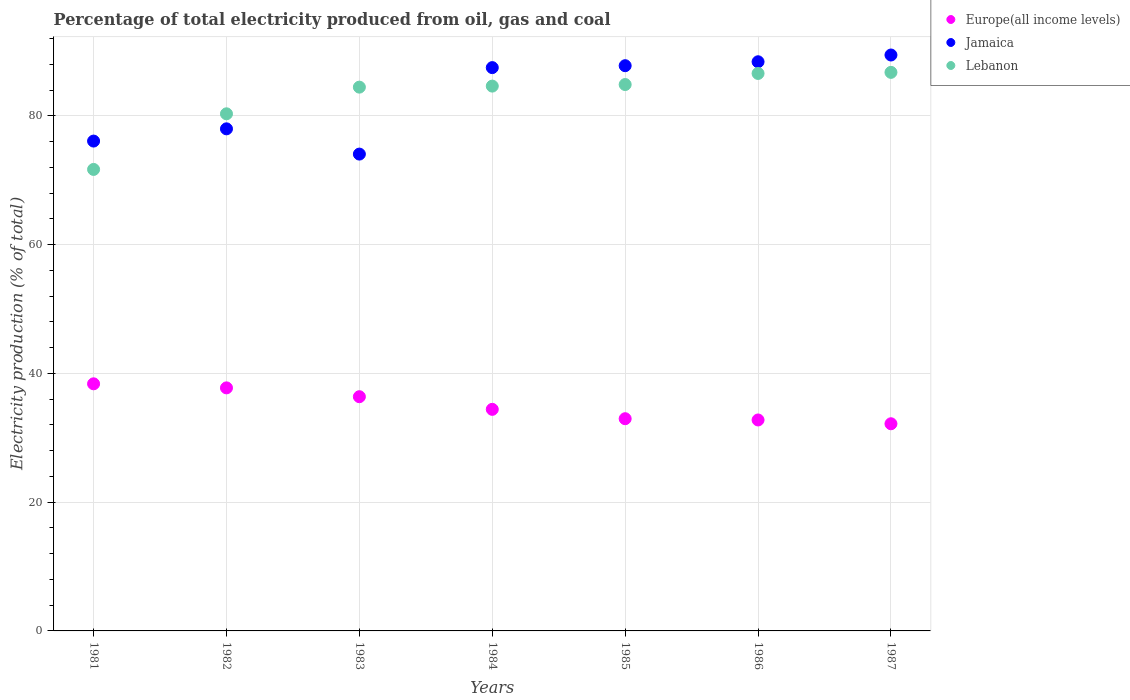Is the number of dotlines equal to the number of legend labels?
Provide a short and direct response. Yes. What is the electricity production in in Lebanon in 1981?
Your response must be concise. 71.67. Across all years, what is the maximum electricity production in in Jamaica?
Offer a very short reply. 89.43. Across all years, what is the minimum electricity production in in Lebanon?
Give a very brief answer. 71.67. In which year was the electricity production in in Jamaica minimum?
Offer a terse response. 1983. What is the total electricity production in in Jamaica in the graph?
Provide a succinct answer. 581.16. What is the difference between the electricity production in in Lebanon in 1984 and that in 1985?
Keep it short and to the point. -0.24. What is the difference between the electricity production in in Europe(all income levels) in 1985 and the electricity production in in Lebanon in 1987?
Keep it short and to the point. -53.78. What is the average electricity production in in Lebanon per year?
Offer a very short reply. 82.74. In the year 1982, what is the difference between the electricity production in in Europe(all income levels) and electricity production in in Lebanon?
Your answer should be very brief. -42.56. In how many years, is the electricity production in in Lebanon greater than 40 %?
Offer a very short reply. 7. What is the ratio of the electricity production in in Europe(all income levels) in 1982 to that in 1983?
Give a very brief answer. 1.04. Is the electricity production in in Europe(all income levels) in 1982 less than that in 1987?
Keep it short and to the point. No. What is the difference between the highest and the second highest electricity production in in Lebanon?
Give a very brief answer. 0.17. What is the difference between the highest and the lowest electricity production in in Europe(all income levels)?
Offer a terse response. 6.2. In how many years, is the electricity production in in Europe(all income levels) greater than the average electricity production in in Europe(all income levels) taken over all years?
Your response must be concise. 3. Does the electricity production in in Europe(all income levels) monotonically increase over the years?
Offer a terse response. No. Is the electricity production in in Europe(all income levels) strictly greater than the electricity production in in Jamaica over the years?
Your response must be concise. No. Is the electricity production in in Europe(all income levels) strictly less than the electricity production in in Jamaica over the years?
Your response must be concise. Yes. How many dotlines are there?
Provide a succinct answer. 3. How many years are there in the graph?
Provide a succinct answer. 7. Are the values on the major ticks of Y-axis written in scientific E-notation?
Provide a succinct answer. No. Does the graph contain any zero values?
Make the answer very short. No. Where does the legend appear in the graph?
Ensure brevity in your answer.  Top right. How many legend labels are there?
Offer a terse response. 3. How are the legend labels stacked?
Your response must be concise. Vertical. What is the title of the graph?
Provide a short and direct response. Percentage of total electricity produced from oil, gas and coal. Does "Monaco" appear as one of the legend labels in the graph?
Your answer should be very brief. No. What is the label or title of the Y-axis?
Offer a terse response. Electricity production (% of total). What is the Electricity production (% of total) in Europe(all income levels) in 1981?
Keep it short and to the point. 38.37. What is the Electricity production (% of total) of Jamaica in 1981?
Make the answer very short. 76.07. What is the Electricity production (% of total) of Lebanon in 1981?
Your answer should be very brief. 71.67. What is the Electricity production (% of total) of Europe(all income levels) in 1982?
Provide a short and direct response. 37.74. What is the Electricity production (% of total) in Jamaica in 1982?
Give a very brief answer. 77.97. What is the Electricity production (% of total) in Lebanon in 1982?
Offer a very short reply. 80.3. What is the Electricity production (% of total) of Europe(all income levels) in 1983?
Give a very brief answer. 36.37. What is the Electricity production (% of total) of Jamaica in 1983?
Make the answer very short. 74.05. What is the Electricity production (% of total) of Lebanon in 1983?
Give a very brief answer. 84.44. What is the Electricity production (% of total) of Europe(all income levels) in 1984?
Your response must be concise. 34.41. What is the Electricity production (% of total) of Jamaica in 1984?
Give a very brief answer. 87.48. What is the Electricity production (% of total) of Lebanon in 1984?
Offer a very short reply. 84.61. What is the Electricity production (% of total) in Europe(all income levels) in 1985?
Your answer should be compact. 32.95. What is the Electricity production (% of total) in Jamaica in 1985?
Provide a short and direct response. 87.78. What is the Electricity production (% of total) in Lebanon in 1985?
Ensure brevity in your answer.  84.85. What is the Electricity production (% of total) of Europe(all income levels) in 1986?
Your answer should be very brief. 32.76. What is the Electricity production (% of total) of Jamaica in 1986?
Make the answer very short. 88.39. What is the Electricity production (% of total) of Lebanon in 1986?
Your answer should be compact. 86.57. What is the Electricity production (% of total) in Europe(all income levels) in 1987?
Offer a very short reply. 32.17. What is the Electricity production (% of total) in Jamaica in 1987?
Make the answer very short. 89.43. What is the Electricity production (% of total) of Lebanon in 1987?
Offer a very short reply. 86.74. Across all years, what is the maximum Electricity production (% of total) in Europe(all income levels)?
Your answer should be compact. 38.37. Across all years, what is the maximum Electricity production (% of total) in Jamaica?
Make the answer very short. 89.43. Across all years, what is the maximum Electricity production (% of total) of Lebanon?
Make the answer very short. 86.74. Across all years, what is the minimum Electricity production (% of total) in Europe(all income levels)?
Your answer should be very brief. 32.17. Across all years, what is the minimum Electricity production (% of total) of Jamaica?
Make the answer very short. 74.05. Across all years, what is the minimum Electricity production (% of total) in Lebanon?
Provide a short and direct response. 71.67. What is the total Electricity production (% of total) in Europe(all income levels) in the graph?
Keep it short and to the point. 244.78. What is the total Electricity production (% of total) of Jamaica in the graph?
Provide a succinct answer. 581.16. What is the total Electricity production (% of total) of Lebanon in the graph?
Make the answer very short. 579.18. What is the difference between the Electricity production (% of total) of Europe(all income levels) in 1981 and that in 1982?
Make the answer very short. 0.63. What is the difference between the Electricity production (% of total) in Jamaica in 1981 and that in 1982?
Provide a succinct answer. -1.9. What is the difference between the Electricity production (% of total) of Lebanon in 1981 and that in 1982?
Provide a succinct answer. -8.64. What is the difference between the Electricity production (% of total) of Europe(all income levels) in 1981 and that in 1983?
Provide a short and direct response. 2. What is the difference between the Electricity production (% of total) in Jamaica in 1981 and that in 1983?
Make the answer very short. 2.02. What is the difference between the Electricity production (% of total) of Lebanon in 1981 and that in 1983?
Ensure brevity in your answer.  -12.78. What is the difference between the Electricity production (% of total) in Europe(all income levels) in 1981 and that in 1984?
Your answer should be compact. 3.96. What is the difference between the Electricity production (% of total) of Jamaica in 1981 and that in 1984?
Your answer should be compact. -11.41. What is the difference between the Electricity production (% of total) in Lebanon in 1981 and that in 1984?
Your answer should be very brief. -12.94. What is the difference between the Electricity production (% of total) in Europe(all income levels) in 1981 and that in 1985?
Provide a short and direct response. 5.42. What is the difference between the Electricity production (% of total) of Jamaica in 1981 and that in 1985?
Offer a very short reply. -11.71. What is the difference between the Electricity production (% of total) in Lebanon in 1981 and that in 1985?
Offer a very short reply. -13.18. What is the difference between the Electricity production (% of total) in Europe(all income levels) in 1981 and that in 1986?
Make the answer very short. 5.61. What is the difference between the Electricity production (% of total) of Jamaica in 1981 and that in 1986?
Make the answer very short. -12.32. What is the difference between the Electricity production (% of total) in Lebanon in 1981 and that in 1986?
Offer a very short reply. -14.9. What is the difference between the Electricity production (% of total) of Europe(all income levels) in 1981 and that in 1987?
Your response must be concise. 6.2. What is the difference between the Electricity production (% of total) of Jamaica in 1981 and that in 1987?
Offer a very short reply. -13.37. What is the difference between the Electricity production (% of total) of Lebanon in 1981 and that in 1987?
Offer a terse response. -15.07. What is the difference between the Electricity production (% of total) of Europe(all income levels) in 1982 and that in 1983?
Your response must be concise. 1.37. What is the difference between the Electricity production (% of total) in Jamaica in 1982 and that in 1983?
Your answer should be compact. 3.92. What is the difference between the Electricity production (% of total) of Lebanon in 1982 and that in 1983?
Keep it short and to the point. -4.14. What is the difference between the Electricity production (% of total) of Europe(all income levels) in 1982 and that in 1984?
Offer a terse response. 3.33. What is the difference between the Electricity production (% of total) of Jamaica in 1982 and that in 1984?
Give a very brief answer. -9.51. What is the difference between the Electricity production (% of total) of Lebanon in 1982 and that in 1984?
Keep it short and to the point. -4.3. What is the difference between the Electricity production (% of total) of Europe(all income levels) in 1982 and that in 1985?
Keep it short and to the point. 4.79. What is the difference between the Electricity production (% of total) in Jamaica in 1982 and that in 1985?
Offer a terse response. -9.81. What is the difference between the Electricity production (% of total) of Lebanon in 1982 and that in 1985?
Ensure brevity in your answer.  -4.55. What is the difference between the Electricity production (% of total) of Europe(all income levels) in 1982 and that in 1986?
Give a very brief answer. 4.98. What is the difference between the Electricity production (% of total) of Jamaica in 1982 and that in 1986?
Offer a very short reply. -10.42. What is the difference between the Electricity production (% of total) of Lebanon in 1982 and that in 1986?
Your answer should be very brief. -6.27. What is the difference between the Electricity production (% of total) of Europe(all income levels) in 1982 and that in 1987?
Keep it short and to the point. 5.57. What is the difference between the Electricity production (% of total) in Jamaica in 1982 and that in 1987?
Keep it short and to the point. -11.46. What is the difference between the Electricity production (% of total) in Lebanon in 1982 and that in 1987?
Keep it short and to the point. -6.44. What is the difference between the Electricity production (% of total) in Europe(all income levels) in 1983 and that in 1984?
Give a very brief answer. 1.96. What is the difference between the Electricity production (% of total) of Jamaica in 1983 and that in 1984?
Provide a short and direct response. -13.43. What is the difference between the Electricity production (% of total) of Lebanon in 1983 and that in 1984?
Offer a terse response. -0.16. What is the difference between the Electricity production (% of total) in Europe(all income levels) in 1983 and that in 1985?
Offer a very short reply. 3.42. What is the difference between the Electricity production (% of total) in Jamaica in 1983 and that in 1985?
Your answer should be very brief. -13.73. What is the difference between the Electricity production (% of total) of Lebanon in 1983 and that in 1985?
Offer a very short reply. -0.4. What is the difference between the Electricity production (% of total) in Europe(all income levels) in 1983 and that in 1986?
Offer a terse response. 3.61. What is the difference between the Electricity production (% of total) of Jamaica in 1983 and that in 1986?
Your response must be concise. -14.34. What is the difference between the Electricity production (% of total) in Lebanon in 1983 and that in 1986?
Your answer should be compact. -2.13. What is the difference between the Electricity production (% of total) in Europe(all income levels) in 1983 and that in 1987?
Your answer should be very brief. 4.2. What is the difference between the Electricity production (% of total) in Jamaica in 1983 and that in 1987?
Provide a succinct answer. -15.39. What is the difference between the Electricity production (% of total) in Lebanon in 1983 and that in 1987?
Your answer should be compact. -2.29. What is the difference between the Electricity production (% of total) of Europe(all income levels) in 1984 and that in 1985?
Keep it short and to the point. 1.45. What is the difference between the Electricity production (% of total) of Jamaica in 1984 and that in 1985?
Your answer should be compact. -0.3. What is the difference between the Electricity production (% of total) of Lebanon in 1984 and that in 1985?
Your response must be concise. -0.24. What is the difference between the Electricity production (% of total) in Europe(all income levels) in 1984 and that in 1986?
Provide a short and direct response. 1.65. What is the difference between the Electricity production (% of total) in Jamaica in 1984 and that in 1986?
Provide a succinct answer. -0.91. What is the difference between the Electricity production (% of total) of Lebanon in 1984 and that in 1986?
Your answer should be compact. -1.97. What is the difference between the Electricity production (% of total) of Europe(all income levels) in 1984 and that in 1987?
Your answer should be very brief. 2.24. What is the difference between the Electricity production (% of total) in Jamaica in 1984 and that in 1987?
Give a very brief answer. -1.96. What is the difference between the Electricity production (% of total) in Lebanon in 1984 and that in 1987?
Give a very brief answer. -2.13. What is the difference between the Electricity production (% of total) in Europe(all income levels) in 1985 and that in 1986?
Offer a terse response. 0.2. What is the difference between the Electricity production (% of total) of Jamaica in 1985 and that in 1986?
Make the answer very short. -0.61. What is the difference between the Electricity production (% of total) of Lebanon in 1985 and that in 1986?
Provide a short and direct response. -1.72. What is the difference between the Electricity production (% of total) in Europe(all income levels) in 1985 and that in 1987?
Your answer should be compact. 0.79. What is the difference between the Electricity production (% of total) of Jamaica in 1985 and that in 1987?
Your response must be concise. -1.66. What is the difference between the Electricity production (% of total) in Lebanon in 1985 and that in 1987?
Keep it short and to the point. -1.89. What is the difference between the Electricity production (% of total) of Europe(all income levels) in 1986 and that in 1987?
Provide a succinct answer. 0.59. What is the difference between the Electricity production (% of total) of Jamaica in 1986 and that in 1987?
Ensure brevity in your answer.  -1.05. What is the difference between the Electricity production (% of total) in Lebanon in 1986 and that in 1987?
Provide a short and direct response. -0.17. What is the difference between the Electricity production (% of total) in Europe(all income levels) in 1981 and the Electricity production (% of total) in Jamaica in 1982?
Offer a terse response. -39.6. What is the difference between the Electricity production (% of total) of Europe(all income levels) in 1981 and the Electricity production (% of total) of Lebanon in 1982?
Ensure brevity in your answer.  -41.93. What is the difference between the Electricity production (% of total) in Jamaica in 1981 and the Electricity production (% of total) in Lebanon in 1982?
Ensure brevity in your answer.  -4.23. What is the difference between the Electricity production (% of total) in Europe(all income levels) in 1981 and the Electricity production (% of total) in Jamaica in 1983?
Ensure brevity in your answer.  -35.67. What is the difference between the Electricity production (% of total) in Europe(all income levels) in 1981 and the Electricity production (% of total) in Lebanon in 1983?
Make the answer very short. -46.07. What is the difference between the Electricity production (% of total) of Jamaica in 1981 and the Electricity production (% of total) of Lebanon in 1983?
Your answer should be very brief. -8.38. What is the difference between the Electricity production (% of total) of Europe(all income levels) in 1981 and the Electricity production (% of total) of Jamaica in 1984?
Offer a terse response. -49.1. What is the difference between the Electricity production (% of total) of Europe(all income levels) in 1981 and the Electricity production (% of total) of Lebanon in 1984?
Your response must be concise. -46.23. What is the difference between the Electricity production (% of total) of Jamaica in 1981 and the Electricity production (% of total) of Lebanon in 1984?
Offer a terse response. -8.54. What is the difference between the Electricity production (% of total) of Europe(all income levels) in 1981 and the Electricity production (% of total) of Jamaica in 1985?
Make the answer very short. -49.4. What is the difference between the Electricity production (% of total) of Europe(all income levels) in 1981 and the Electricity production (% of total) of Lebanon in 1985?
Ensure brevity in your answer.  -46.47. What is the difference between the Electricity production (% of total) in Jamaica in 1981 and the Electricity production (% of total) in Lebanon in 1985?
Provide a succinct answer. -8.78. What is the difference between the Electricity production (% of total) in Europe(all income levels) in 1981 and the Electricity production (% of total) in Jamaica in 1986?
Ensure brevity in your answer.  -50.01. What is the difference between the Electricity production (% of total) in Europe(all income levels) in 1981 and the Electricity production (% of total) in Lebanon in 1986?
Your answer should be compact. -48.2. What is the difference between the Electricity production (% of total) of Jamaica in 1981 and the Electricity production (% of total) of Lebanon in 1986?
Offer a terse response. -10.5. What is the difference between the Electricity production (% of total) of Europe(all income levels) in 1981 and the Electricity production (% of total) of Jamaica in 1987?
Offer a terse response. -51.06. What is the difference between the Electricity production (% of total) of Europe(all income levels) in 1981 and the Electricity production (% of total) of Lebanon in 1987?
Provide a succinct answer. -48.37. What is the difference between the Electricity production (% of total) in Jamaica in 1981 and the Electricity production (% of total) in Lebanon in 1987?
Give a very brief answer. -10.67. What is the difference between the Electricity production (% of total) in Europe(all income levels) in 1982 and the Electricity production (% of total) in Jamaica in 1983?
Your answer should be very brief. -36.3. What is the difference between the Electricity production (% of total) in Europe(all income levels) in 1982 and the Electricity production (% of total) in Lebanon in 1983?
Ensure brevity in your answer.  -46.7. What is the difference between the Electricity production (% of total) in Jamaica in 1982 and the Electricity production (% of total) in Lebanon in 1983?
Give a very brief answer. -6.47. What is the difference between the Electricity production (% of total) in Europe(all income levels) in 1982 and the Electricity production (% of total) in Jamaica in 1984?
Offer a very short reply. -49.73. What is the difference between the Electricity production (% of total) in Europe(all income levels) in 1982 and the Electricity production (% of total) in Lebanon in 1984?
Offer a very short reply. -46.86. What is the difference between the Electricity production (% of total) of Jamaica in 1982 and the Electricity production (% of total) of Lebanon in 1984?
Ensure brevity in your answer.  -6.64. What is the difference between the Electricity production (% of total) in Europe(all income levels) in 1982 and the Electricity production (% of total) in Jamaica in 1985?
Give a very brief answer. -50.03. What is the difference between the Electricity production (% of total) in Europe(all income levels) in 1982 and the Electricity production (% of total) in Lebanon in 1985?
Your answer should be compact. -47.11. What is the difference between the Electricity production (% of total) in Jamaica in 1982 and the Electricity production (% of total) in Lebanon in 1985?
Make the answer very short. -6.88. What is the difference between the Electricity production (% of total) in Europe(all income levels) in 1982 and the Electricity production (% of total) in Jamaica in 1986?
Give a very brief answer. -50.64. What is the difference between the Electricity production (% of total) of Europe(all income levels) in 1982 and the Electricity production (% of total) of Lebanon in 1986?
Provide a short and direct response. -48.83. What is the difference between the Electricity production (% of total) of Jamaica in 1982 and the Electricity production (% of total) of Lebanon in 1986?
Keep it short and to the point. -8.6. What is the difference between the Electricity production (% of total) of Europe(all income levels) in 1982 and the Electricity production (% of total) of Jamaica in 1987?
Keep it short and to the point. -51.69. What is the difference between the Electricity production (% of total) of Europe(all income levels) in 1982 and the Electricity production (% of total) of Lebanon in 1987?
Your answer should be very brief. -49. What is the difference between the Electricity production (% of total) in Jamaica in 1982 and the Electricity production (% of total) in Lebanon in 1987?
Make the answer very short. -8.77. What is the difference between the Electricity production (% of total) of Europe(all income levels) in 1983 and the Electricity production (% of total) of Jamaica in 1984?
Your answer should be very brief. -51.11. What is the difference between the Electricity production (% of total) of Europe(all income levels) in 1983 and the Electricity production (% of total) of Lebanon in 1984?
Your answer should be compact. -48.23. What is the difference between the Electricity production (% of total) in Jamaica in 1983 and the Electricity production (% of total) in Lebanon in 1984?
Offer a very short reply. -10.56. What is the difference between the Electricity production (% of total) of Europe(all income levels) in 1983 and the Electricity production (% of total) of Jamaica in 1985?
Provide a succinct answer. -51.4. What is the difference between the Electricity production (% of total) of Europe(all income levels) in 1983 and the Electricity production (% of total) of Lebanon in 1985?
Your answer should be very brief. -48.48. What is the difference between the Electricity production (% of total) of Jamaica in 1983 and the Electricity production (% of total) of Lebanon in 1985?
Provide a short and direct response. -10.8. What is the difference between the Electricity production (% of total) of Europe(all income levels) in 1983 and the Electricity production (% of total) of Jamaica in 1986?
Give a very brief answer. -52.01. What is the difference between the Electricity production (% of total) of Europe(all income levels) in 1983 and the Electricity production (% of total) of Lebanon in 1986?
Provide a succinct answer. -50.2. What is the difference between the Electricity production (% of total) of Jamaica in 1983 and the Electricity production (% of total) of Lebanon in 1986?
Offer a very short reply. -12.52. What is the difference between the Electricity production (% of total) in Europe(all income levels) in 1983 and the Electricity production (% of total) in Jamaica in 1987?
Give a very brief answer. -53.06. What is the difference between the Electricity production (% of total) in Europe(all income levels) in 1983 and the Electricity production (% of total) in Lebanon in 1987?
Provide a short and direct response. -50.37. What is the difference between the Electricity production (% of total) of Jamaica in 1983 and the Electricity production (% of total) of Lebanon in 1987?
Give a very brief answer. -12.69. What is the difference between the Electricity production (% of total) of Europe(all income levels) in 1984 and the Electricity production (% of total) of Jamaica in 1985?
Your answer should be compact. -53.37. What is the difference between the Electricity production (% of total) in Europe(all income levels) in 1984 and the Electricity production (% of total) in Lebanon in 1985?
Offer a very short reply. -50.44. What is the difference between the Electricity production (% of total) in Jamaica in 1984 and the Electricity production (% of total) in Lebanon in 1985?
Give a very brief answer. 2.63. What is the difference between the Electricity production (% of total) in Europe(all income levels) in 1984 and the Electricity production (% of total) in Jamaica in 1986?
Make the answer very short. -53.98. What is the difference between the Electricity production (% of total) in Europe(all income levels) in 1984 and the Electricity production (% of total) in Lebanon in 1986?
Provide a short and direct response. -52.16. What is the difference between the Electricity production (% of total) of Jamaica in 1984 and the Electricity production (% of total) of Lebanon in 1986?
Provide a succinct answer. 0.91. What is the difference between the Electricity production (% of total) in Europe(all income levels) in 1984 and the Electricity production (% of total) in Jamaica in 1987?
Keep it short and to the point. -55.03. What is the difference between the Electricity production (% of total) of Europe(all income levels) in 1984 and the Electricity production (% of total) of Lebanon in 1987?
Your answer should be very brief. -52.33. What is the difference between the Electricity production (% of total) of Jamaica in 1984 and the Electricity production (% of total) of Lebanon in 1987?
Your answer should be very brief. 0.74. What is the difference between the Electricity production (% of total) of Europe(all income levels) in 1985 and the Electricity production (% of total) of Jamaica in 1986?
Offer a terse response. -55.43. What is the difference between the Electricity production (% of total) of Europe(all income levels) in 1985 and the Electricity production (% of total) of Lebanon in 1986?
Your answer should be compact. -53.62. What is the difference between the Electricity production (% of total) of Jamaica in 1985 and the Electricity production (% of total) of Lebanon in 1986?
Your answer should be compact. 1.2. What is the difference between the Electricity production (% of total) in Europe(all income levels) in 1985 and the Electricity production (% of total) in Jamaica in 1987?
Your answer should be compact. -56.48. What is the difference between the Electricity production (% of total) of Europe(all income levels) in 1985 and the Electricity production (% of total) of Lebanon in 1987?
Give a very brief answer. -53.78. What is the difference between the Electricity production (% of total) in Jamaica in 1985 and the Electricity production (% of total) in Lebanon in 1987?
Give a very brief answer. 1.04. What is the difference between the Electricity production (% of total) of Europe(all income levels) in 1986 and the Electricity production (% of total) of Jamaica in 1987?
Make the answer very short. -56.67. What is the difference between the Electricity production (% of total) of Europe(all income levels) in 1986 and the Electricity production (% of total) of Lebanon in 1987?
Your answer should be compact. -53.98. What is the difference between the Electricity production (% of total) in Jamaica in 1986 and the Electricity production (% of total) in Lebanon in 1987?
Your answer should be compact. 1.65. What is the average Electricity production (% of total) of Europe(all income levels) per year?
Your answer should be very brief. 34.97. What is the average Electricity production (% of total) in Jamaica per year?
Provide a short and direct response. 83.02. What is the average Electricity production (% of total) of Lebanon per year?
Provide a short and direct response. 82.74. In the year 1981, what is the difference between the Electricity production (% of total) in Europe(all income levels) and Electricity production (% of total) in Jamaica?
Give a very brief answer. -37.7. In the year 1981, what is the difference between the Electricity production (% of total) of Europe(all income levels) and Electricity production (% of total) of Lebanon?
Provide a short and direct response. -33.29. In the year 1981, what is the difference between the Electricity production (% of total) of Jamaica and Electricity production (% of total) of Lebanon?
Offer a very short reply. 4.4. In the year 1982, what is the difference between the Electricity production (% of total) of Europe(all income levels) and Electricity production (% of total) of Jamaica?
Ensure brevity in your answer.  -40.23. In the year 1982, what is the difference between the Electricity production (% of total) of Europe(all income levels) and Electricity production (% of total) of Lebanon?
Make the answer very short. -42.56. In the year 1982, what is the difference between the Electricity production (% of total) of Jamaica and Electricity production (% of total) of Lebanon?
Make the answer very short. -2.33. In the year 1983, what is the difference between the Electricity production (% of total) in Europe(all income levels) and Electricity production (% of total) in Jamaica?
Provide a succinct answer. -37.68. In the year 1983, what is the difference between the Electricity production (% of total) in Europe(all income levels) and Electricity production (% of total) in Lebanon?
Ensure brevity in your answer.  -48.07. In the year 1983, what is the difference between the Electricity production (% of total) in Jamaica and Electricity production (% of total) in Lebanon?
Make the answer very short. -10.4. In the year 1984, what is the difference between the Electricity production (% of total) of Europe(all income levels) and Electricity production (% of total) of Jamaica?
Offer a very short reply. -53.07. In the year 1984, what is the difference between the Electricity production (% of total) in Europe(all income levels) and Electricity production (% of total) in Lebanon?
Give a very brief answer. -50.2. In the year 1984, what is the difference between the Electricity production (% of total) of Jamaica and Electricity production (% of total) of Lebanon?
Give a very brief answer. 2.87. In the year 1985, what is the difference between the Electricity production (% of total) in Europe(all income levels) and Electricity production (% of total) in Jamaica?
Provide a succinct answer. -54.82. In the year 1985, what is the difference between the Electricity production (% of total) in Europe(all income levels) and Electricity production (% of total) in Lebanon?
Your answer should be very brief. -51.89. In the year 1985, what is the difference between the Electricity production (% of total) of Jamaica and Electricity production (% of total) of Lebanon?
Make the answer very short. 2.93. In the year 1986, what is the difference between the Electricity production (% of total) of Europe(all income levels) and Electricity production (% of total) of Jamaica?
Give a very brief answer. -55.63. In the year 1986, what is the difference between the Electricity production (% of total) of Europe(all income levels) and Electricity production (% of total) of Lebanon?
Offer a terse response. -53.81. In the year 1986, what is the difference between the Electricity production (% of total) in Jamaica and Electricity production (% of total) in Lebanon?
Offer a very short reply. 1.81. In the year 1987, what is the difference between the Electricity production (% of total) in Europe(all income levels) and Electricity production (% of total) in Jamaica?
Ensure brevity in your answer.  -57.26. In the year 1987, what is the difference between the Electricity production (% of total) of Europe(all income levels) and Electricity production (% of total) of Lebanon?
Offer a terse response. -54.57. In the year 1987, what is the difference between the Electricity production (% of total) of Jamaica and Electricity production (% of total) of Lebanon?
Ensure brevity in your answer.  2.69. What is the ratio of the Electricity production (% of total) in Europe(all income levels) in 1981 to that in 1982?
Offer a terse response. 1.02. What is the ratio of the Electricity production (% of total) of Jamaica in 1981 to that in 1982?
Keep it short and to the point. 0.98. What is the ratio of the Electricity production (% of total) of Lebanon in 1981 to that in 1982?
Your answer should be very brief. 0.89. What is the ratio of the Electricity production (% of total) in Europe(all income levels) in 1981 to that in 1983?
Your answer should be very brief. 1.06. What is the ratio of the Electricity production (% of total) in Jamaica in 1981 to that in 1983?
Provide a succinct answer. 1.03. What is the ratio of the Electricity production (% of total) of Lebanon in 1981 to that in 1983?
Ensure brevity in your answer.  0.85. What is the ratio of the Electricity production (% of total) of Europe(all income levels) in 1981 to that in 1984?
Provide a succinct answer. 1.12. What is the ratio of the Electricity production (% of total) of Jamaica in 1981 to that in 1984?
Provide a succinct answer. 0.87. What is the ratio of the Electricity production (% of total) in Lebanon in 1981 to that in 1984?
Your response must be concise. 0.85. What is the ratio of the Electricity production (% of total) of Europe(all income levels) in 1981 to that in 1985?
Offer a terse response. 1.16. What is the ratio of the Electricity production (% of total) in Jamaica in 1981 to that in 1985?
Your answer should be compact. 0.87. What is the ratio of the Electricity production (% of total) of Lebanon in 1981 to that in 1985?
Your answer should be compact. 0.84. What is the ratio of the Electricity production (% of total) of Europe(all income levels) in 1981 to that in 1986?
Your answer should be very brief. 1.17. What is the ratio of the Electricity production (% of total) of Jamaica in 1981 to that in 1986?
Provide a succinct answer. 0.86. What is the ratio of the Electricity production (% of total) of Lebanon in 1981 to that in 1986?
Offer a terse response. 0.83. What is the ratio of the Electricity production (% of total) in Europe(all income levels) in 1981 to that in 1987?
Offer a terse response. 1.19. What is the ratio of the Electricity production (% of total) of Jamaica in 1981 to that in 1987?
Make the answer very short. 0.85. What is the ratio of the Electricity production (% of total) in Lebanon in 1981 to that in 1987?
Keep it short and to the point. 0.83. What is the ratio of the Electricity production (% of total) of Europe(all income levels) in 1982 to that in 1983?
Provide a short and direct response. 1.04. What is the ratio of the Electricity production (% of total) in Jamaica in 1982 to that in 1983?
Give a very brief answer. 1.05. What is the ratio of the Electricity production (% of total) in Lebanon in 1982 to that in 1983?
Ensure brevity in your answer.  0.95. What is the ratio of the Electricity production (% of total) in Europe(all income levels) in 1982 to that in 1984?
Ensure brevity in your answer.  1.1. What is the ratio of the Electricity production (% of total) of Jamaica in 1982 to that in 1984?
Offer a very short reply. 0.89. What is the ratio of the Electricity production (% of total) of Lebanon in 1982 to that in 1984?
Provide a succinct answer. 0.95. What is the ratio of the Electricity production (% of total) in Europe(all income levels) in 1982 to that in 1985?
Offer a very short reply. 1.15. What is the ratio of the Electricity production (% of total) of Jamaica in 1982 to that in 1985?
Keep it short and to the point. 0.89. What is the ratio of the Electricity production (% of total) in Lebanon in 1982 to that in 1985?
Make the answer very short. 0.95. What is the ratio of the Electricity production (% of total) in Europe(all income levels) in 1982 to that in 1986?
Provide a short and direct response. 1.15. What is the ratio of the Electricity production (% of total) of Jamaica in 1982 to that in 1986?
Provide a short and direct response. 0.88. What is the ratio of the Electricity production (% of total) in Lebanon in 1982 to that in 1986?
Ensure brevity in your answer.  0.93. What is the ratio of the Electricity production (% of total) in Europe(all income levels) in 1982 to that in 1987?
Ensure brevity in your answer.  1.17. What is the ratio of the Electricity production (% of total) in Jamaica in 1982 to that in 1987?
Make the answer very short. 0.87. What is the ratio of the Electricity production (% of total) of Lebanon in 1982 to that in 1987?
Provide a succinct answer. 0.93. What is the ratio of the Electricity production (% of total) in Europe(all income levels) in 1983 to that in 1984?
Provide a succinct answer. 1.06. What is the ratio of the Electricity production (% of total) in Jamaica in 1983 to that in 1984?
Your answer should be very brief. 0.85. What is the ratio of the Electricity production (% of total) in Europe(all income levels) in 1983 to that in 1985?
Provide a succinct answer. 1.1. What is the ratio of the Electricity production (% of total) of Jamaica in 1983 to that in 1985?
Your response must be concise. 0.84. What is the ratio of the Electricity production (% of total) of Lebanon in 1983 to that in 1985?
Provide a short and direct response. 1. What is the ratio of the Electricity production (% of total) of Europe(all income levels) in 1983 to that in 1986?
Provide a succinct answer. 1.11. What is the ratio of the Electricity production (% of total) in Jamaica in 1983 to that in 1986?
Offer a very short reply. 0.84. What is the ratio of the Electricity production (% of total) in Lebanon in 1983 to that in 1986?
Provide a short and direct response. 0.98. What is the ratio of the Electricity production (% of total) of Europe(all income levels) in 1983 to that in 1987?
Your answer should be compact. 1.13. What is the ratio of the Electricity production (% of total) of Jamaica in 1983 to that in 1987?
Offer a terse response. 0.83. What is the ratio of the Electricity production (% of total) in Lebanon in 1983 to that in 1987?
Ensure brevity in your answer.  0.97. What is the ratio of the Electricity production (% of total) of Europe(all income levels) in 1984 to that in 1985?
Ensure brevity in your answer.  1.04. What is the ratio of the Electricity production (% of total) of Europe(all income levels) in 1984 to that in 1986?
Give a very brief answer. 1.05. What is the ratio of the Electricity production (% of total) of Jamaica in 1984 to that in 1986?
Your answer should be compact. 0.99. What is the ratio of the Electricity production (% of total) in Lebanon in 1984 to that in 1986?
Your answer should be compact. 0.98. What is the ratio of the Electricity production (% of total) of Europe(all income levels) in 1984 to that in 1987?
Provide a succinct answer. 1.07. What is the ratio of the Electricity production (% of total) in Jamaica in 1984 to that in 1987?
Offer a very short reply. 0.98. What is the ratio of the Electricity production (% of total) in Lebanon in 1984 to that in 1987?
Keep it short and to the point. 0.98. What is the ratio of the Electricity production (% of total) of Jamaica in 1985 to that in 1986?
Your answer should be compact. 0.99. What is the ratio of the Electricity production (% of total) in Lebanon in 1985 to that in 1986?
Offer a very short reply. 0.98. What is the ratio of the Electricity production (% of total) of Europe(all income levels) in 1985 to that in 1987?
Your response must be concise. 1.02. What is the ratio of the Electricity production (% of total) in Jamaica in 1985 to that in 1987?
Make the answer very short. 0.98. What is the ratio of the Electricity production (% of total) in Lebanon in 1985 to that in 1987?
Your answer should be compact. 0.98. What is the ratio of the Electricity production (% of total) of Europe(all income levels) in 1986 to that in 1987?
Your answer should be very brief. 1.02. What is the ratio of the Electricity production (% of total) of Jamaica in 1986 to that in 1987?
Ensure brevity in your answer.  0.99. What is the difference between the highest and the second highest Electricity production (% of total) of Europe(all income levels)?
Provide a succinct answer. 0.63. What is the difference between the highest and the second highest Electricity production (% of total) in Jamaica?
Ensure brevity in your answer.  1.05. What is the difference between the highest and the second highest Electricity production (% of total) of Lebanon?
Your response must be concise. 0.17. What is the difference between the highest and the lowest Electricity production (% of total) of Europe(all income levels)?
Provide a short and direct response. 6.2. What is the difference between the highest and the lowest Electricity production (% of total) of Jamaica?
Offer a terse response. 15.39. What is the difference between the highest and the lowest Electricity production (% of total) in Lebanon?
Your answer should be very brief. 15.07. 